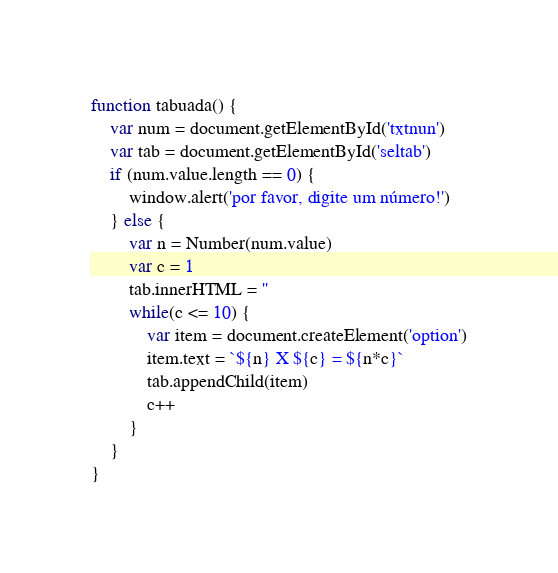Convert code to text. <code><loc_0><loc_0><loc_500><loc_500><_JavaScript_>function tabuada() {
    var num = document.getElementById('txtnun')
    var tab = document.getElementById('seltab')
    if (num.value.length == 0) {
        window.alert('por favor, digite um número!')
    } else {
        var n = Number(num.value)
        var c = 1
        tab.innerHTML = ''
        while(c <= 10) {
            var item = document.createElement('option')
            item.text = `${n} X ${c} = ${n*c}`
            tab.appendChild(item)
            c++
        }
    }
}</code> 